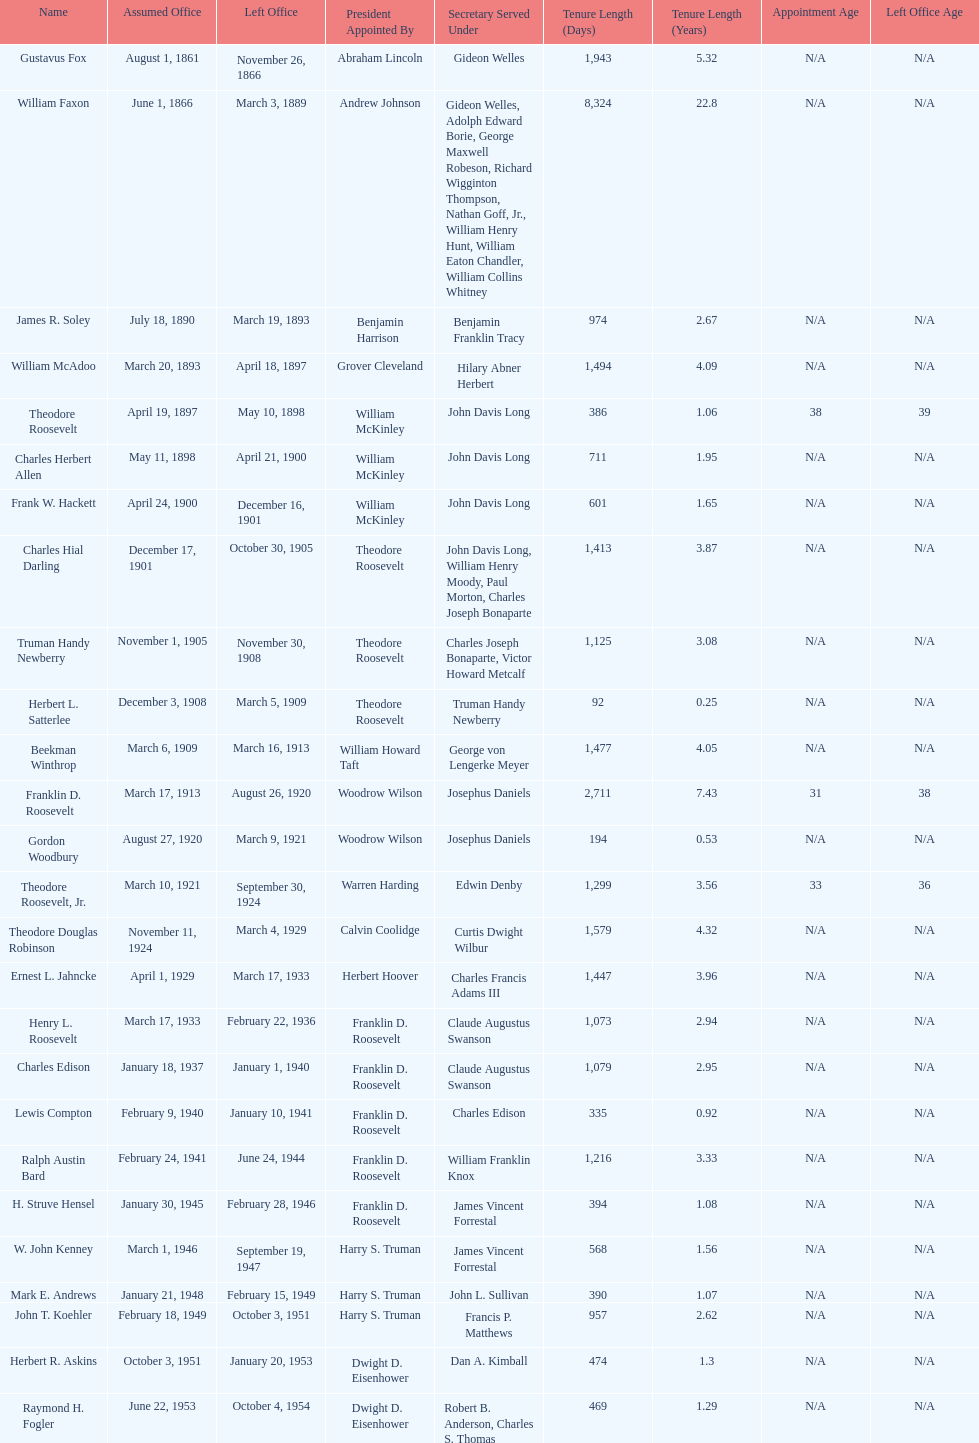When did raymond h. fogler leave the office of assistant secretary of the navy? October 4, 1954. 